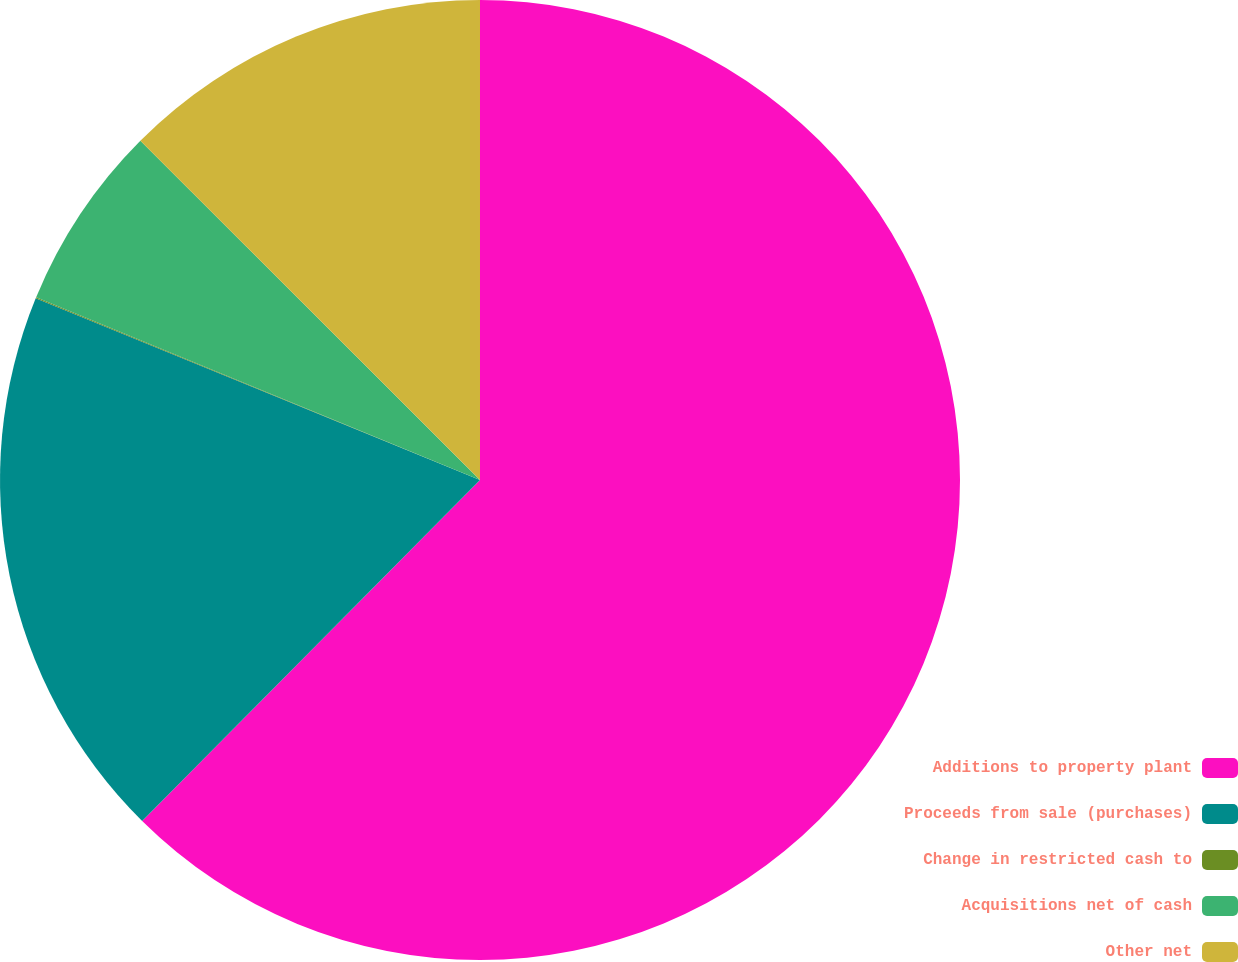Convert chart to OTSL. <chart><loc_0><loc_0><loc_500><loc_500><pie_chart><fcel>Additions to property plant<fcel>Proceeds from sale (purchases)<fcel>Change in restricted cash to<fcel>Acquisitions net of cash<fcel>Other net<nl><fcel>62.42%<fcel>18.75%<fcel>0.04%<fcel>6.27%<fcel>12.51%<nl></chart> 